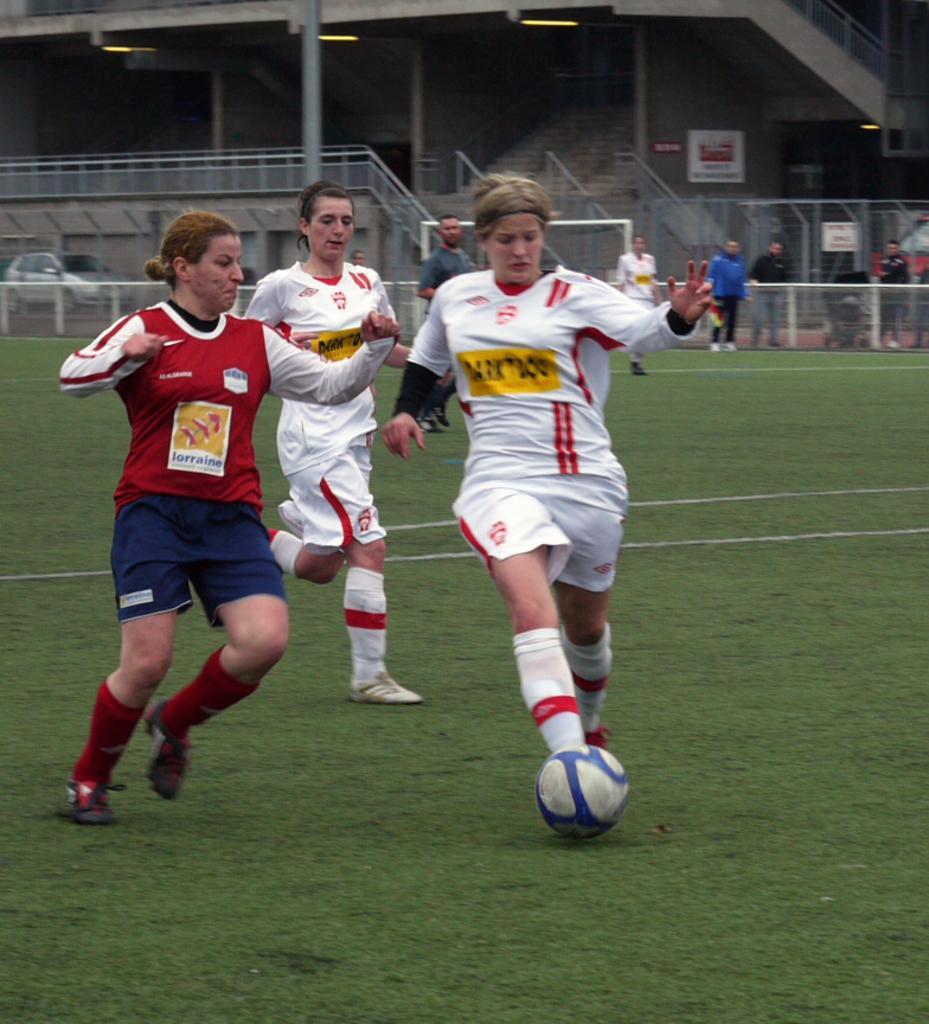Can you describe this image briefly? This picture shows three women playing a football game, the girl in front is kicking football, in the background we can see barrel gates and some of the people standing over there and also we can see stairs up there. 